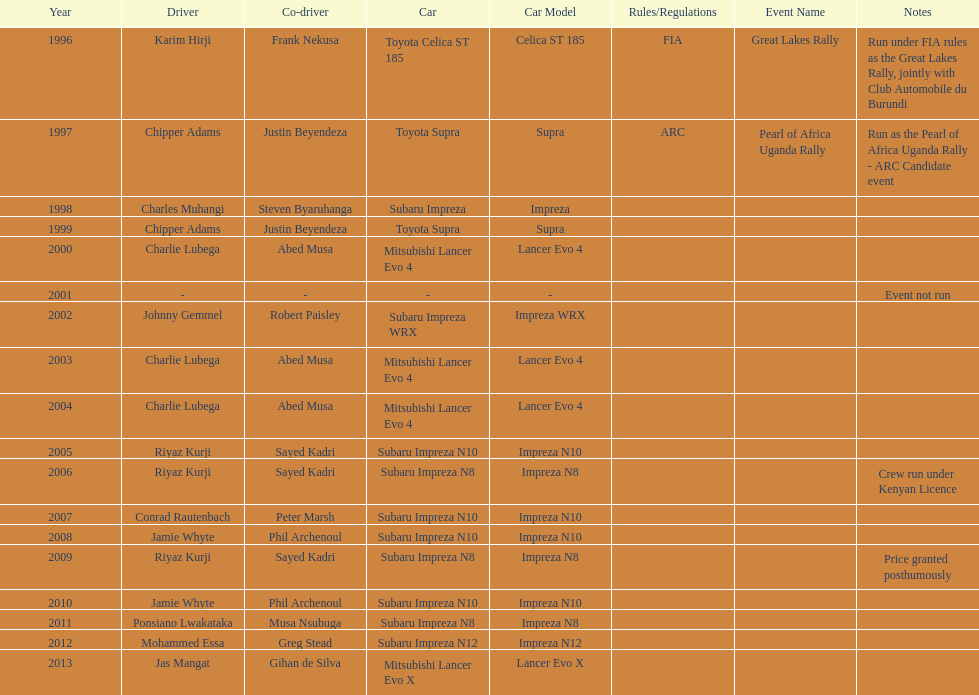What is the total number of times that the winning driver was driving a toyota supra? 2. 